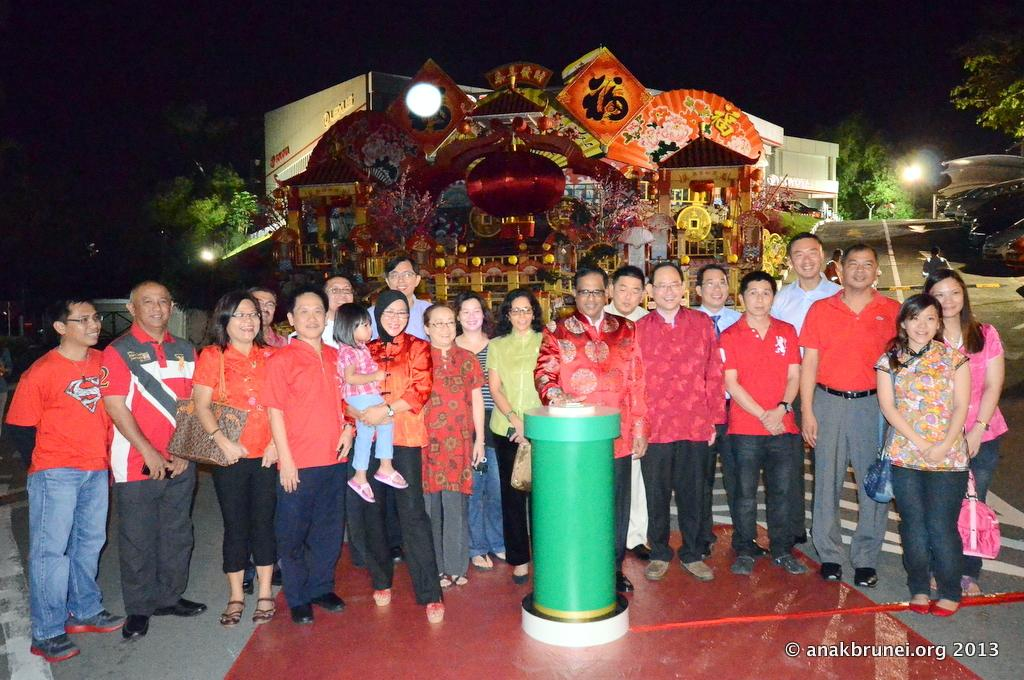What can be seen in the image? There are people standing in the image. What is visible in the background of the image? There are trees and a building in the background of the image. What verse is being recited by the people in the image? There is no indication in the image that the people are reciting a verse, so it cannot be determined from the picture. 